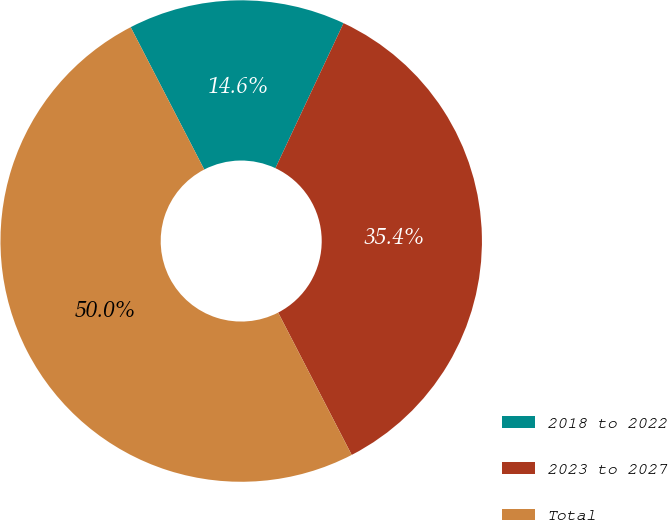Convert chart. <chart><loc_0><loc_0><loc_500><loc_500><pie_chart><fcel>2018 to 2022<fcel>2023 to 2027<fcel>Total<nl><fcel>14.58%<fcel>35.42%<fcel>50.0%<nl></chart> 